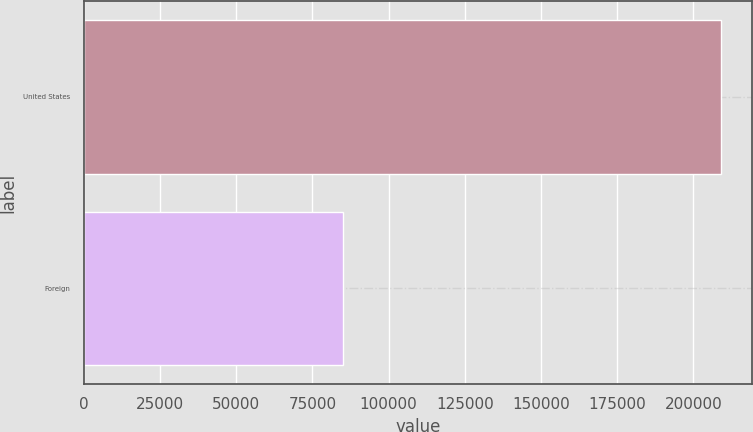<chart> <loc_0><loc_0><loc_500><loc_500><bar_chart><fcel>United States<fcel>Foreign<nl><fcel>208926<fcel>84960<nl></chart> 